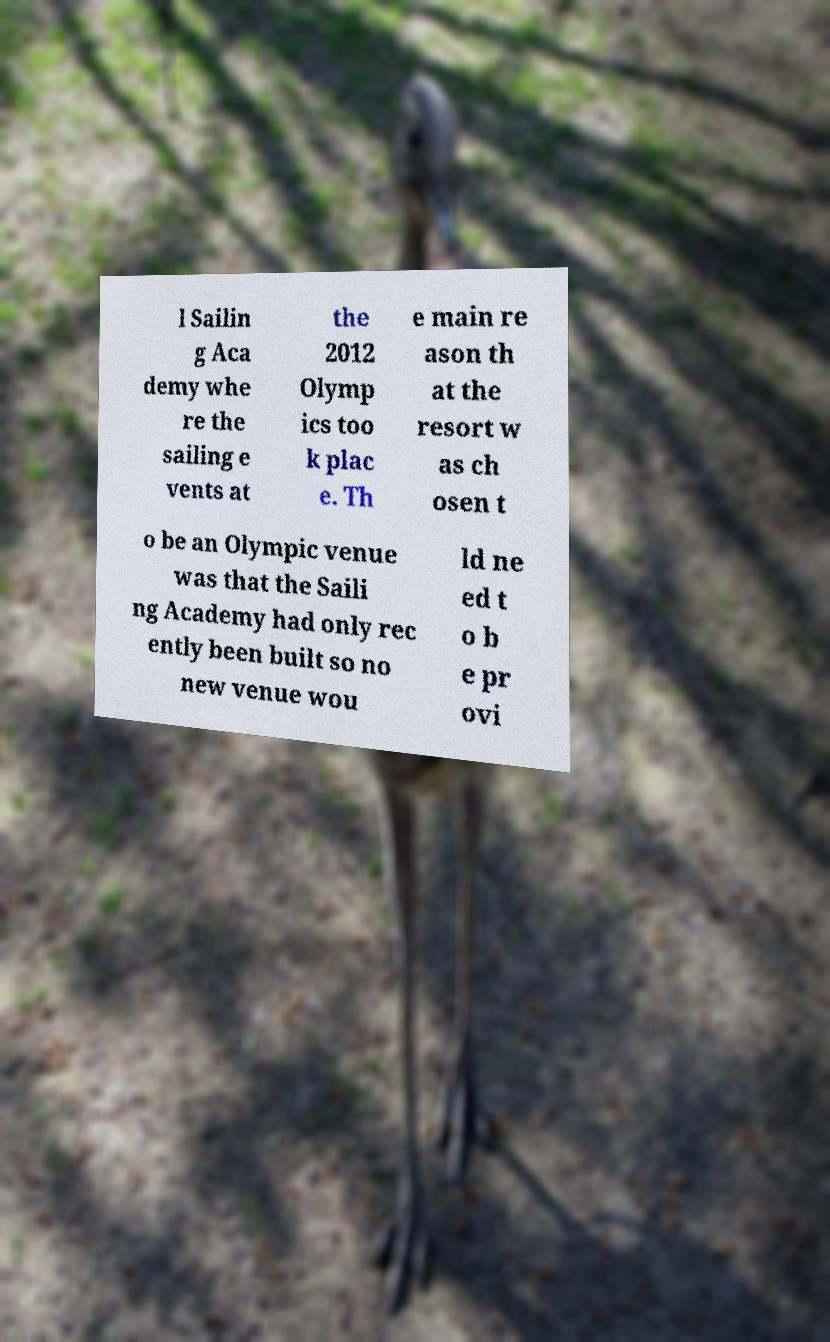Could you extract and type out the text from this image? l Sailin g Aca demy whe re the sailing e vents at the 2012 Olymp ics too k plac e. Th e main re ason th at the resort w as ch osen t o be an Olympic venue was that the Saili ng Academy had only rec ently been built so no new venue wou ld ne ed t o b e pr ovi 